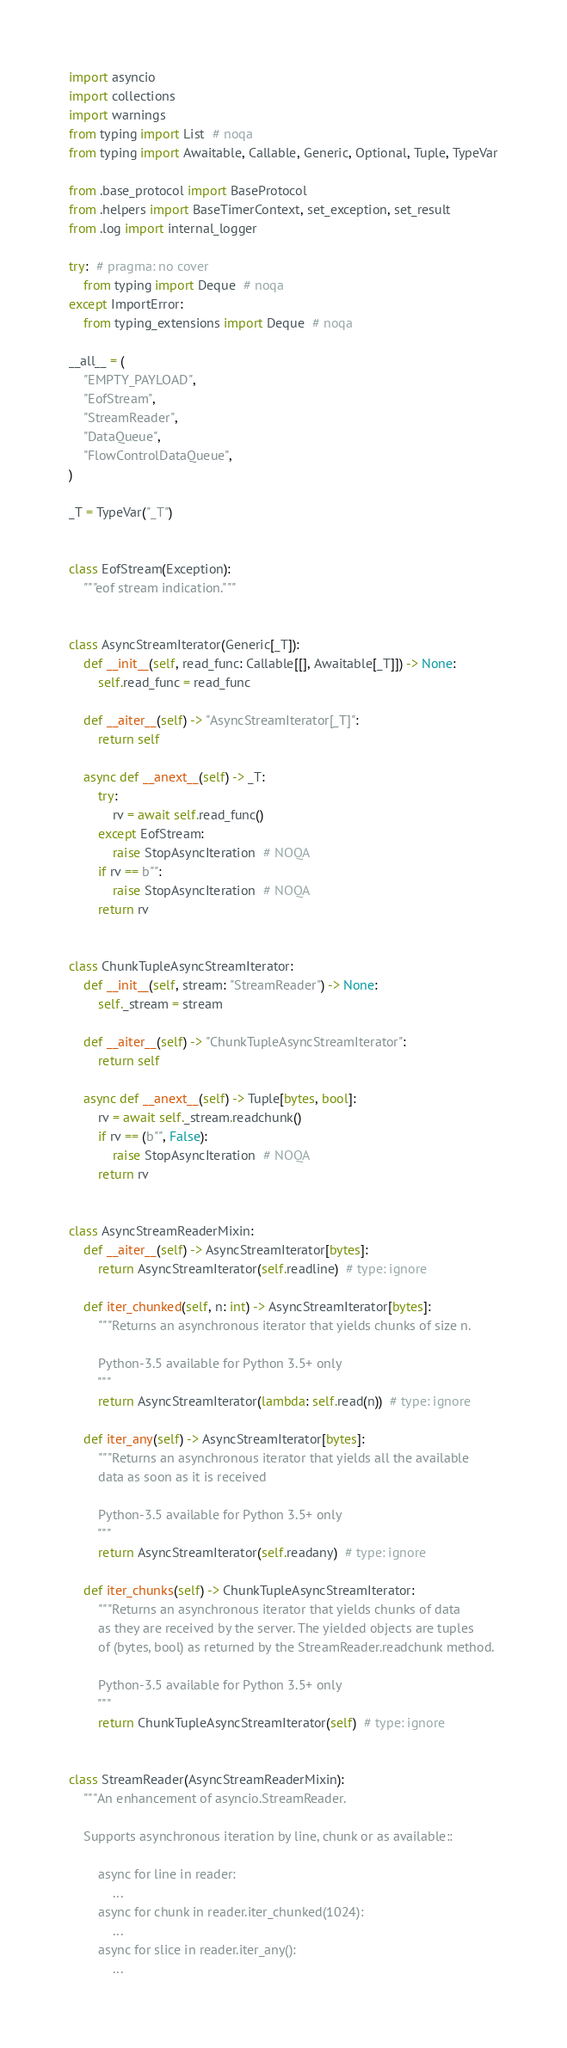<code> <loc_0><loc_0><loc_500><loc_500><_Python_>import asyncio
import collections
import warnings
from typing import List  # noqa
from typing import Awaitable, Callable, Generic, Optional, Tuple, TypeVar

from .base_protocol import BaseProtocol
from .helpers import BaseTimerContext, set_exception, set_result
from .log import internal_logger

try:  # pragma: no cover
    from typing import Deque  # noqa
except ImportError:
    from typing_extensions import Deque  # noqa

__all__ = (
    "EMPTY_PAYLOAD",
    "EofStream",
    "StreamReader",
    "DataQueue",
    "FlowControlDataQueue",
)

_T = TypeVar("_T")


class EofStream(Exception):
    """eof stream indication."""


class AsyncStreamIterator(Generic[_T]):
    def __init__(self, read_func: Callable[[], Awaitable[_T]]) -> None:
        self.read_func = read_func

    def __aiter__(self) -> "AsyncStreamIterator[_T]":
        return self

    async def __anext__(self) -> _T:
        try:
            rv = await self.read_func()
        except EofStream:
            raise StopAsyncIteration  # NOQA
        if rv == b"":
            raise StopAsyncIteration  # NOQA
        return rv


class ChunkTupleAsyncStreamIterator:
    def __init__(self, stream: "StreamReader") -> None:
        self._stream = stream

    def __aiter__(self) -> "ChunkTupleAsyncStreamIterator":
        return self

    async def __anext__(self) -> Tuple[bytes, bool]:
        rv = await self._stream.readchunk()
        if rv == (b"", False):
            raise StopAsyncIteration  # NOQA
        return rv


class AsyncStreamReaderMixin:
    def __aiter__(self) -> AsyncStreamIterator[bytes]:
        return AsyncStreamIterator(self.readline)  # type: ignore

    def iter_chunked(self, n: int) -> AsyncStreamIterator[bytes]:
        """Returns an asynchronous iterator that yields chunks of size n.

        Python-3.5 available for Python 3.5+ only
        """
        return AsyncStreamIterator(lambda: self.read(n))  # type: ignore

    def iter_any(self) -> AsyncStreamIterator[bytes]:
        """Returns an asynchronous iterator that yields all the available
        data as soon as it is received

        Python-3.5 available for Python 3.5+ only
        """
        return AsyncStreamIterator(self.readany)  # type: ignore

    def iter_chunks(self) -> ChunkTupleAsyncStreamIterator:
        """Returns an asynchronous iterator that yields chunks of data
        as they are received by the server. The yielded objects are tuples
        of (bytes, bool) as returned by the StreamReader.readchunk method.

        Python-3.5 available for Python 3.5+ only
        """
        return ChunkTupleAsyncStreamIterator(self)  # type: ignore


class StreamReader(AsyncStreamReaderMixin):
    """An enhancement of asyncio.StreamReader.

    Supports asynchronous iteration by line, chunk or as available::

        async for line in reader:
            ...
        async for chunk in reader.iter_chunked(1024):
            ...
        async for slice in reader.iter_any():
            ...
</code> 